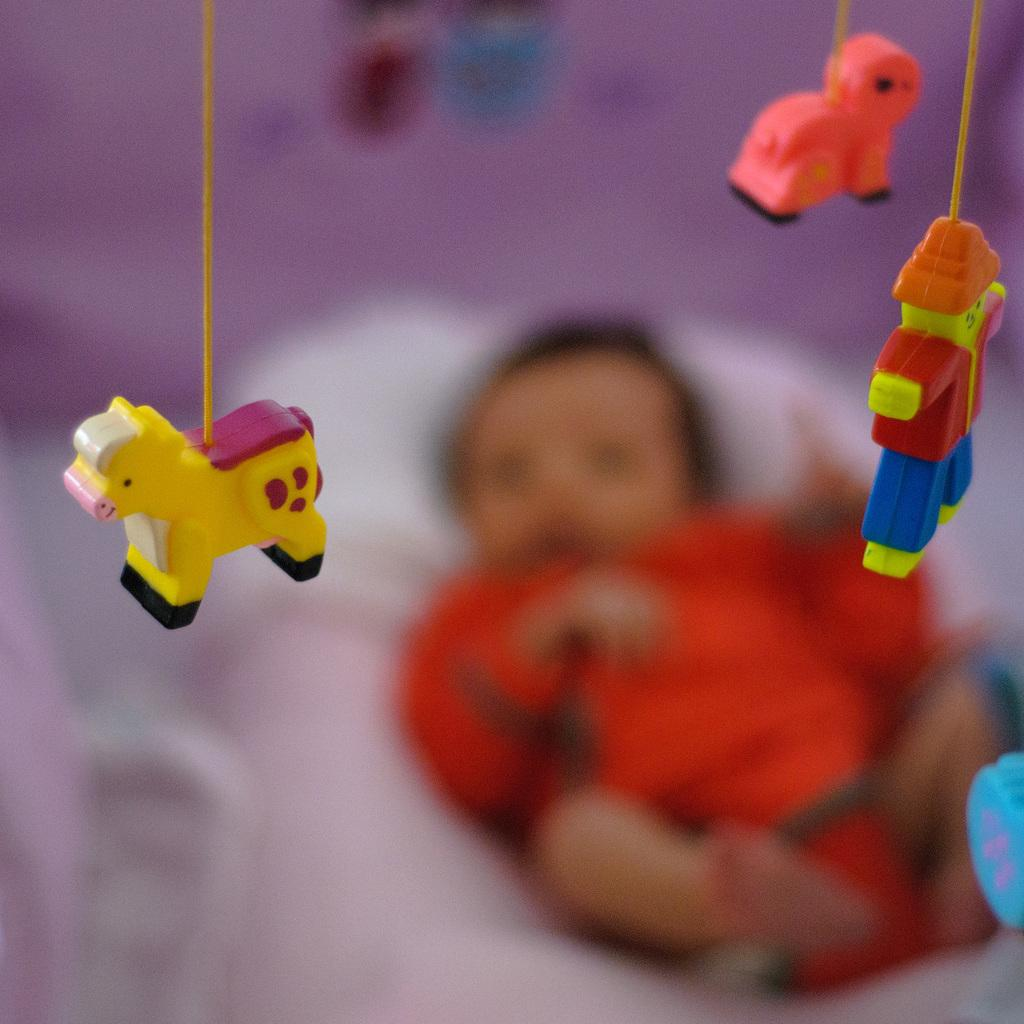How many toys are visible in the image? There are 3 toys in the image. What is the position of the toys in the image? The toys are hanged to ropes. What can be seen in the background of the image? There is a baby in the background of the image. What is the baby doing in the image? The baby is lying down. How clear is the image of the baby? The baby appears blurred in the background. What type of sleet can be seen falling on the toys in the image? There is no sleet present in the image; it is an indoor scene with no precipitation. 